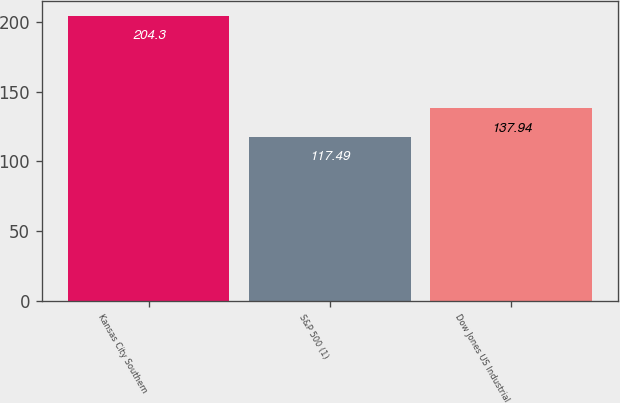Convert chart to OTSL. <chart><loc_0><loc_0><loc_500><loc_500><bar_chart><fcel>Kansas City Southern<fcel>S&P 500 (1)<fcel>Dow Jones US Industrial<nl><fcel>204.3<fcel>117.49<fcel>137.94<nl></chart> 